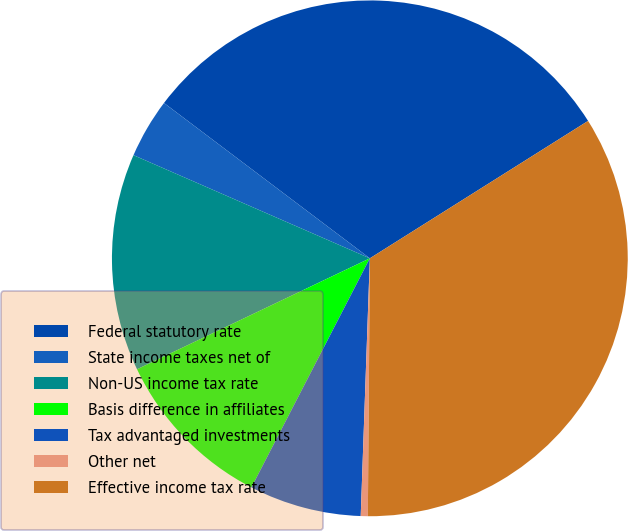Convert chart to OTSL. <chart><loc_0><loc_0><loc_500><loc_500><pie_chart><fcel>Federal statutory rate<fcel>State income taxes net of<fcel>Non-US income tax rate<fcel>Basis difference in affiliates<fcel>Tax advantaged investments<fcel>Other net<fcel>Effective income tax rate<nl><fcel>30.77%<fcel>3.74%<fcel>13.63%<fcel>10.33%<fcel>7.03%<fcel>0.44%<fcel>34.07%<nl></chart> 